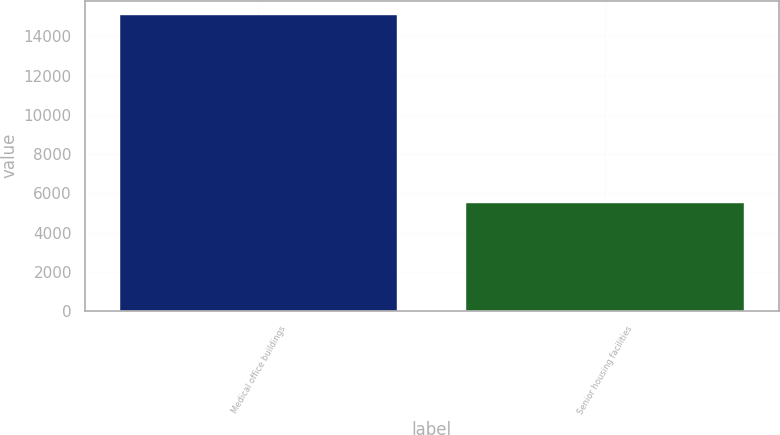Convert chart to OTSL. <chart><loc_0><loc_0><loc_500><loc_500><bar_chart><fcel>Medical office buildings<fcel>Senior housing facilities<nl><fcel>15072<fcel>5490<nl></chart> 